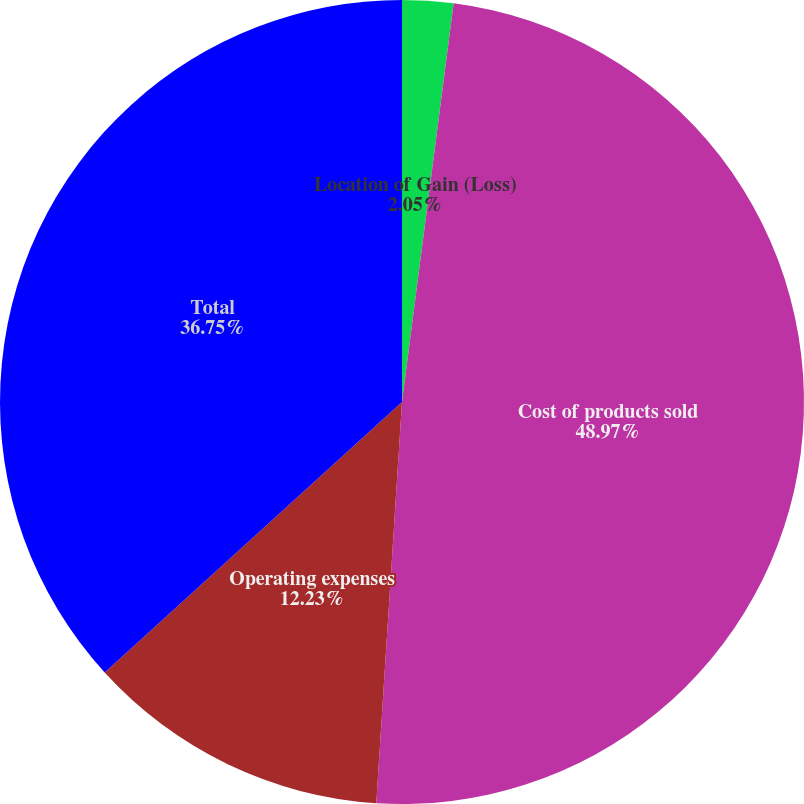<chart> <loc_0><loc_0><loc_500><loc_500><pie_chart><fcel>Location of Gain (Loss)<fcel>Cost of products sold<fcel>Operating expenses<fcel>Total<nl><fcel>2.05%<fcel>48.97%<fcel>12.23%<fcel>36.75%<nl></chart> 